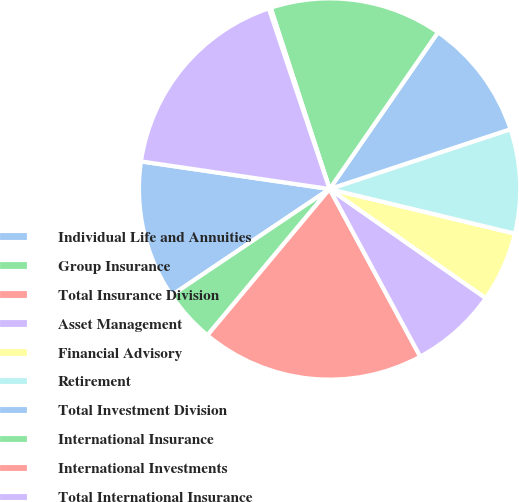<chart> <loc_0><loc_0><loc_500><loc_500><pie_chart><fcel>Individual Life and Annuities<fcel>Group Insurance<fcel>Total Insurance Division<fcel>Asset Management<fcel>Financial Advisory<fcel>Retirement<fcel>Total Investment Division<fcel>International Insurance<fcel>International Investments<fcel>Total International Insurance<nl><fcel>11.74%<fcel>4.5%<fcel>18.97%<fcel>7.4%<fcel>5.95%<fcel>8.84%<fcel>10.29%<fcel>14.63%<fcel>0.17%<fcel>17.52%<nl></chart> 